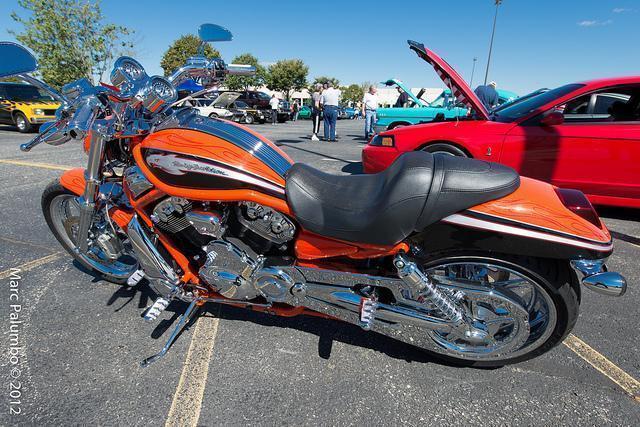What is the silver area of the bike made of?
Choose the right answer from the provided options to respond to the question.
Options: Glass, chrome, pewter, plastic. Chrome. 